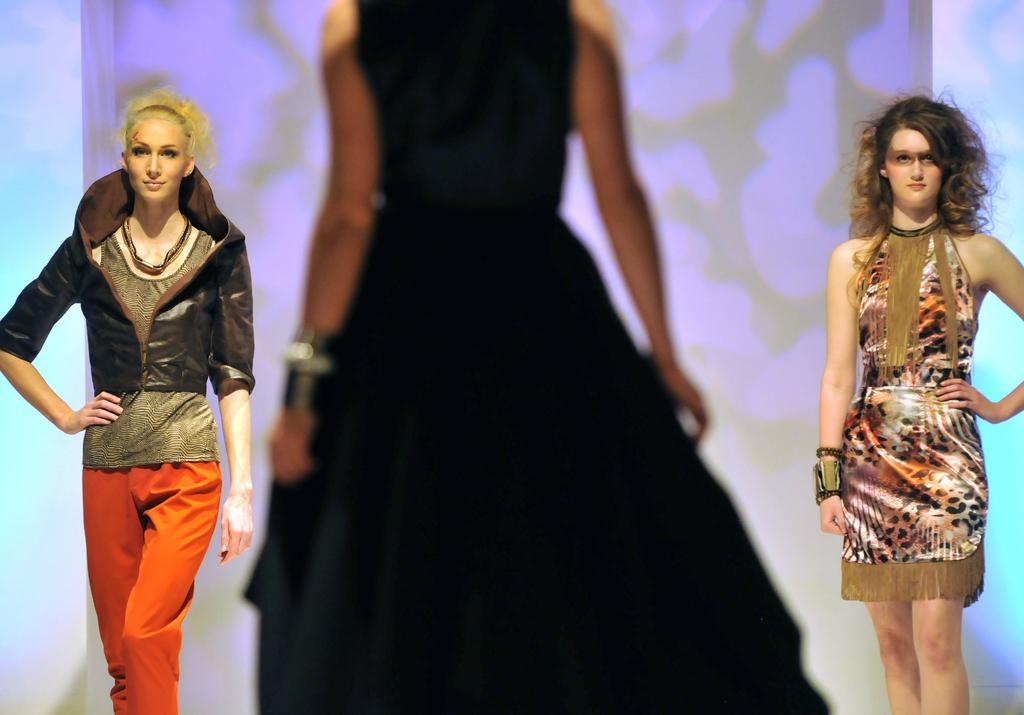How many people are in the image? There are three women in the image. What are the women doing in the image? The women are standing on the floor. What type of comfort does the son provide to the women in the image? There is no son present in the image, so it is not possible to determine what comfort he might provide. 